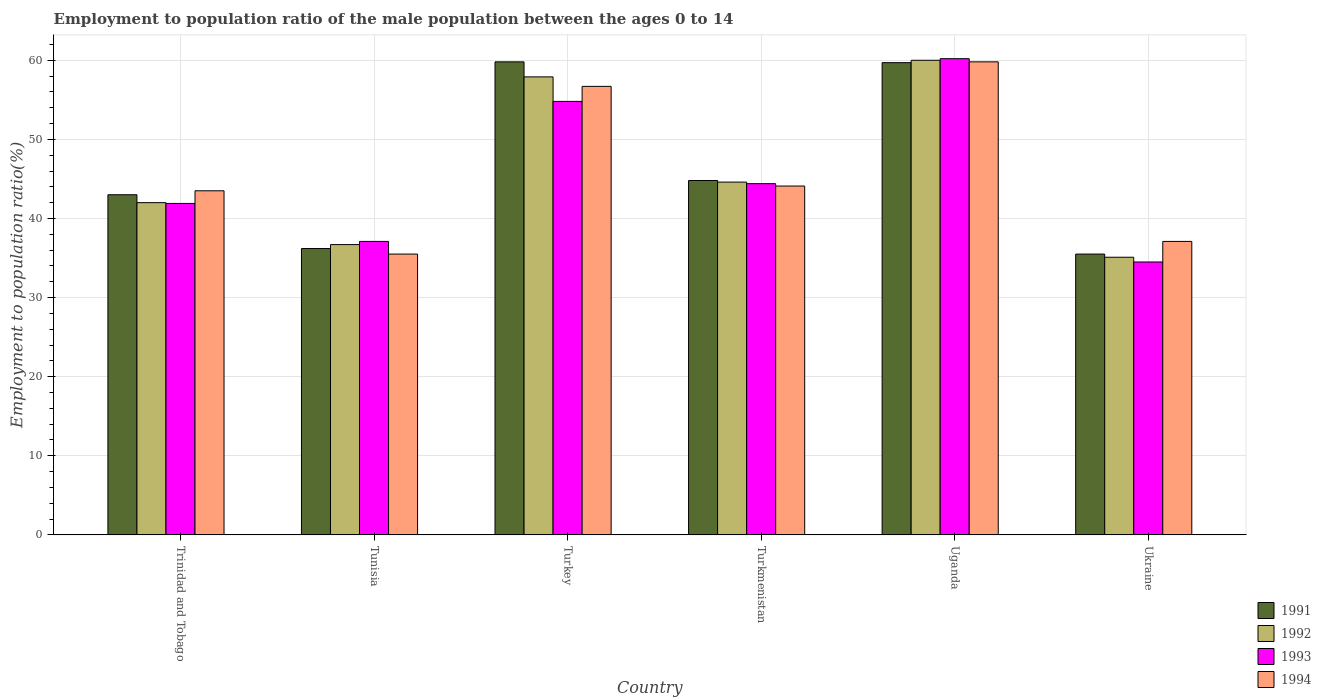How many groups of bars are there?
Give a very brief answer. 6. Are the number of bars per tick equal to the number of legend labels?
Keep it short and to the point. Yes. Are the number of bars on each tick of the X-axis equal?
Ensure brevity in your answer.  Yes. What is the label of the 4th group of bars from the left?
Give a very brief answer. Turkmenistan. What is the employment to population ratio in 1991 in Uganda?
Your response must be concise. 59.7. Across all countries, what is the maximum employment to population ratio in 1993?
Offer a terse response. 60.2. Across all countries, what is the minimum employment to population ratio in 1994?
Provide a short and direct response. 35.5. In which country was the employment to population ratio in 1991 minimum?
Your answer should be very brief. Ukraine. What is the total employment to population ratio in 1992 in the graph?
Provide a short and direct response. 276.3. What is the difference between the employment to population ratio in 1991 in Tunisia and the employment to population ratio in 1993 in Turkmenistan?
Provide a short and direct response. -8.2. What is the average employment to population ratio in 1992 per country?
Offer a very short reply. 46.05. What is the difference between the employment to population ratio of/in 1994 and employment to population ratio of/in 1993 in Trinidad and Tobago?
Provide a succinct answer. 1.6. What is the ratio of the employment to population ratio in 1993 in Turkey to that in Uganda?
Provide a succinct answer. 0.91. Is the difference between the employment to population ratio in 1994 in Turkey and Ukraine greater than the difference between the employment to population ratio in 1993 in Turkey and Ukraine?
Your answer should be very brief. No. What is the difference between the highest and the second highest employment to population ratio in 1991?
Keep it short and to the point. -0.1. What is the difference between the highest and the lowest employment to population ratio in 1992?
Your response must be concise. 24.9. In how many countries, is the employment to population ratio in 1991 greater than the average employment to population ratio in 1991 taken over all countries?
Keep it short and to the point. 2. Is it the case that in every country, the sum of the employment to population ratio in 1993 and employment to population ratio in 1992 is greater than the sum of employment to population ratio in 1991 and employment to population ratio in 1994?
Offer a very short reply. No. Is it the case that in every country, the sum of the employment to population ratio in 1994 and employment to population ratio in 1991 is greater than the employment to population ratio in 1992?
Provide a succinct answer. Yes. How many bars are there?
Ensure brevity in your answer.  24. Are all the bars in the graph horizontal?
Your response must be concise. No. How many countries are there in the graph?
Offer a very short reply. 6. What is the difference between two consecutive major ticks on the Y-axis?
Offer a very short reply. 10. Where does the legend appear in the graph?
Give a very brief answer. Bottom right. How many legend labels are there?
Provide a succinct answer. 4. How are the legend labels stacked?
Your answer should be compact. Vertical. What is the title of the graph?
Offer a terse response. Employment to population ratio of the male population between the ages 0 to 14. Does "2002" appear as one of the legend labels in the graph?
Provide a short and direct response. No. What is the label or title of the Y-axis?
Make the answer very short. Employment to population ratio(%). What is the Employment to population ratio(%) in 1991 in Trinidad and Tobago?
Your answer should be compact. 43. What is the Employment to population ratio(%) of 1992 in Trinidad and Tobago?
Provide a succinct answer. 42. What is the Employment to population ratio(%) in 1993 in Trinidad and Tobago?
Your answer should be compact. 41.9. What is the Employment to population ratio(%) of 1994 in Trinidad and Tobago?
Provide a succinct answer. 43.5. What is the Employment to population ratio(%) in 1991 in Tunisia?
Keep it short and to the point. 36.2. What is the Employment to population ratio(%) of 1992 in Tunisia?
Offer a very short reply. 36.7. What is the Employment to population ratio(%) of 1993 in Tunisia?
Your answer should be very brief. 37.1. What is the Employment to population ratio(%) in 1994 in Tunisia?
Make the answer very short. 35.5. What is the Employment to population ratio(%) of 1991 in Turkey?
Offer a terse response. 59.8. What is the Employment to population ratio(%) of 1992 in Turkey?
Offer a terse response. 57.9. What is the Employment to population ratio(%) in 1993 in Turkey?
Provide a succinct answer. 54.8. What is the Employment to population ratio(%) in 1994 in Turkey?
Provide a succinct answer. 56.7. What is the Employment to population ratio(%) of 1991 in Turkmenistan?
Keep it short and to the point. 44.8. What is the Employment to population ratio(%) in 1992 in Turkmenistan?
Offer a very short reply. 44.6. What is the Employment to population ratio(%) of 1993 in Turkmenistan?
Keep it short and to the point. 44.4. What is the Employment to population ratio(%) of 1994 in Turkmenistan?
Your response must be concise. 44.1. What is the Employment to population ratio(%) in 1991 in Uganda?
Ensure brevity in your answer.  59.7. What is the Employment to population ratio(%) in 1992 in Uganda?
Make the answer very short. 60. What is the Employment to population ratio(%) of 1993 in Uganda?
Offer a terse response. 60.2. What is the Employment to population ratio(%) of 1994 in Uganda?
Offer a terse response. 59.8. What is the Employment to population ratio(%) in 1991 in Ukraine?
Offer a terse response. 35.5. What is the Employment to population ratio(%) in 1992 in Ukraine?
Offer a terse response. 35.1. What is the Employment to population ratio(%) in 1993 in Ukraine?
Ensure brevity in your answer.  34.5. What is the Employment to population ratio(%) in 1994 in Ukraine?
Keep it short and to the point. 37.1. Across all countries, what is the maximum Employment to population ratio(%) in 1991?
Keep it short and to the point. 59.8. Across all countries, what is the maximum Employment to population ratio(%) in 1992?
Provide a short and direct response. 60. Across all countries, what is the maximum Employment to population ratio(%) of 1993?
Give a very brief answer. 60.2. Across all countries, what is the maximum Employment to population ratio(%) in 1994?
Offer a terse response. 59.8. Across all countries, what is the minimum Employment to population ratio(%) in 1991?
Ensure brevity in your answer.  35.5. Across all countries, what is the minimum Employment to population ratio(%) of 1992?
Offer a terse response. 35.1. Across all countries, what is the minimum Employment to population ratio(%) of 1993?
Give a very brief answer. 34.5. Across all countries, what is the minimum Employment to population ratio(%) in 1994?
Your response must be concise. 35.5. What is the total Employment to population ratio(%) of 1991 in the graph?
Offer a very short reply. 279. What is the total Employment to population ratio(%) of 1992 in the graph?
Give a very brief answer. 276.3. What is the total Employment to population ratio(%) in 1993 in the graph?
Your answer should be very brief. 272.9. What is the total Employment to population ratio(%) in 1994 in the graph?
Your response must be concise. 276.7. What is the difference between the Employment to population ratio(%) of 1991 in Trinidad and Tobago and that in Tunisia?
Provide a short and direct response. 6.8. What is the difference between the Employment to population ratio(%) in 1992 in Trinidad and Tobago and that in Tunisia?
Keep it short and to the point. 5.3. What is the difference between the Employment to population ratio(%) in 1991 in Trinidad and Tobago and that in Turkey?
Your response must be concise. -16.8. What is the difference between the Employment to population ratio(%) in 1992 in Trinidad and Tobago and that in Turkey?
Offer a very short reply. -15.9. What is the difference between the Employment to population ratio(%) of 1991 in Trinidad and Tobago and that in Turkmenistan?
Your answer should be compact. -1.8. What is the difference between the Employment to population ratio(%) of 1992 in Trinidad and Tobago and that in Turkmenistan?
Your response must be concise. -2.6. What is the difference between the Employment to population ratio(%) of 1993 in Trinidad and Tobago and that in Turkmenistan?
Your answer should be compact. -2.5. What is the difference between the Employment to population ratio(%) of 1994 in Trinidad and Tobago and that in Turkmenistan?
Your response must be concise. -0.6. What is the difference between the Employment to population ratio(%) of 1991 in Trinidad and Tobago and that in Uganda?
Provide a short and direct response. -16.7. What is the difference between the Employment to population ratio(%) of 1992 in Trinidad and Tobago and that in Uganda?
Your answer should be very brief. -18. What is the difference between the Employment to population ratio(%) of 1993 in Trinidad and Tobago and that in Uganda?
Offer a terse response. -18.3. What is the difference between the Employment to population ratio(%) of 1994 in Trinidad and Tobago and that in Uganda?
Your answer should be very brief. -16.3. What is the difference between the Employment to population ratio(%) of 1991 in Trinidad and Tobago and that in Ukraine?
Your answer should be very brief. 7.5. What is the difference between the Employment to population ratio(%) in 1994 in Trinidad and Tobago and that in Ukraine?
Your answer should be very brief. 6.4. What is the difference between the Employment to population ratio(%) of 1991 in Tunisia and that in Turkey?
Your answer should be very brief. -23.6. What is the difference between the Employment to population ratio(%) of 1992 in Tunisia and that in Turkey?
Ensure brevity in your answer.  -21.2. What is the difference between the Employment to population ratio(%) of 1993 in Tunisia and that in Turkey?
Offer a terse response. -17.7. What is the difference between the Employment to population ratio(%) of 1994 in Tunisia and that in Turkey?
Provide a short and direct response. -21.2. What is the difference between the Employment to population ratio(%) in 1991 in Tunisia and that in Turkmenistan?
Your answer should be very brief. -8.6. What is the difference between the Employment to population ratio(%) of 1991 in Tunisia and that in Uganda?
Give a very brief answer. -23.5. What is the difference between the Employment to population ratio(%) of 1992 in Tunisia and that in Uganda?
Your answer should be compact. -23.3. What is the difference between the Employment to population ratio(%) of 1993 in Tunisia and that in Uganda?
Ensure brevity in your answer.  -23.1. What is the difference between the Employment to population ratio(%) in 1994 in Tunisia and that in Uganda?
Provide a succinct answer. -24.3. What is the difference between the Employment to population ratio(%) in 1991 in Tunisia and that in Ukraine?
Give a very brief answer. 0.7. What is the difference between the Employment to population ratio(%) in 1992 in Tunisia and that in Ukraine?
Make the answer very short. 1.6. What is the difference between the Employment to population ratio(%) of 1993 in Tunisia and that in Ukraine?
Offer a very short reply. 2.6. What is the difference between the Employment to population ratio(%) of 1993 in Turkey and that in Uganda?
Your answer should be compact. -5.4. What is the difference between the Employment to population ratio(%) of 1994 in Turkey and that in Uganda?
Your answer should be very brief. -3.1. What is the difference between the Employment to population ratio(%) in 1991 in Turkey and that in Ukraine?
Keep it short and to the point. 24.3. What is the difference between the Employment to population ratio(%) in 1992 in Turkey and that in Ukraine?
Keep it short and to the point. 22.8. What is the difference between the Employment to population ratio(%) in 1993 in Turkey and that in Ukraine?
Give a very brief answer. 20.3. What is the difference between the Employment to population ratio(%) in 1994 in Turkey and that in Ukraine?
Ensure brevity in your answer.  19.6. What is the difference between the Employment to population ratio(%) in 1991 in Turkmenistan and that in Uganda?
Ensure brevity in your answer.  -14.9. What is the difference between the Employment to population ratio(%) of 1992 in Turkmenistan and that in Uganda?
Provide a succinct answer. -15.4. What is the difference between the Employment to population ratio(%) in 1993 in Turkmenistan and that in Uganda?
Offer a very short reply. -15.8. What is the difference between the Employment to population ratio(%) of 1994 in Turkmenistan and that in Uganda?
Make the answer very short. -15.7. What is the difference between the Employment to population ratio(%) of 1991 in Turkmenistan and that in Ukraine?
Your answer should be very brief. 9.3. What is the difference between the Employment to population ratio(%) of 1994 in Turkmenistan and that in Ukraine?
Your response must be concise. 7. What is the difference between the Employment to population ratio(%) in 1991 in Uganda and that in Ukraine?
Offer a very short reply. 24.2. What is the difference between the Employment to population ratio(%) in 1992 in Uganda and that in Ukraine?
Provide a short and direct response. 24.9. What is the difference between the Employment to population ratio(%) in 1993 in Uganda and that in Ukraine?
Offer a very short reply. 25.7. What is the difference between the Employment to population ratio(%) of 1994 in Uganda and that in Ukraine?
Your answer should be compact. 22.7. What is the difference between the Employment to population ratio(%) in 1991 in Trinidad and Tobago and the Employment to population ratio(%) in 1992 in Tunisia?
Your response must be concise. 6.3. What is the difference between the Employment to population ratio(%) in 1991 in Trinidad and Tobago and the Employment to population ratio(%) in 1994 in Tunisia?
Offer a terse response. 7.5. What is the difference between the Employment to population ratio(%) of 1992 in Trinidad and Tobago and the Employment to population ratio(%) of 1994 in Tunisia?
Offer a very short reply. 6.5. What is the difference between the Employment to population ratio(%) in 1991 in Trinidad and Tobago and the Employment to population ratio(%) in 1992 in Turkey?
Offer a very short reply. -14.9. What is the difference between the Employment to population ratio(%) in 1991 in Trinidad and Tobago and the Employment to population ratio(%) in 1994 in Turkey?
Provide a succinct answer. -13.7. What is the difference between the Employment to population ratio(%) of 1992 in Trinidad and Tobago and the Employment to population ratio(%) of 1994 in Turkey?
Your answer should be compact. -14.7. What is the difference between the Employment to population ratio(%) of 1993 in Trinidad and Tobago and the Employment to population ratio(%) of 1994 in Turkey?
Your answer should be very brief. -14.8. What is the difference between the Employment to population ratio(%) of 1991 in Trinidad and Tobago and the Employment to population ratio(%) of 1992 in Turkmenistan?
Your answer should be very brief. -1.6. What is the difference between the Employment to population ratio(%) of 1991 in Trinidad and Tobago and the Employment to population ratio(%) of 1994 in Turkmenistan?
Provide a short and direct response. -1.1. What is the difference between the Employment to population ratio(%) in 1992 in Trinidad and Tobago and the Employment to population ratio(%) in 1993 in Turkmenistan?
Your answer should be compact. -2.4. What is the difference between the Employment to population ratio(%) in 1991 in Trinidad and Tobago and the Employment to population ratio(%) in 1993 in Uganda?
Provide a succinct answer. -17.2. What is the difference between the Employment to population ratio(%) of 1991 in Trinidad and Tobago and the Employment to population ratio(%) of 1994 in Uganda?
Make the answer very short. -16.8. What is the difference between the Employment to population ratio(%) in 1992 in Trinidad and Tobago and the Employment to population ratio(%) in 1993 in Uganda?
Offer a very short reply. -18.2. What is the difference between the Employment to population ratio(%) of 1992 in Trinidad and Tobago and the Employment to population ratio(%) of 1994 in Uganda?
Your answer should be compact. -17.8. What is the difference between the Employment to population ratio(%) of 1993 in Trinidad and Tobago and the Employment to population ratio(%) of 1994 in Uganda?
Your response must be concise. -17.9. What is the difference between the Employment to population ratio(%) of 1991 in Trinidad and Tobago and the Employment to population ratio(%) of 1992 in Ukraine?
Keep it short and to the point. 7.9. What is the difference between the Employment to population ratio(%) in 1991 in Tunisia and the Employment to population ratio(%) in 1992 in Turkey?
Give a very brief answer. -21.7. What is the difference between the Employment to population ratio(%) of 1991 in Tunisia and the Employment to population ratio(%) of 1993 in Turkey?
Provide a succinct answer. -18.6. What is the difference between the Employment to population ratio(%) of 1991 in Tunisia and the Employment to population ratio(%) of 1994 in Turkey?
Ensure brevity in your answer.  -20.5. What is the difference between the Employment to population ratio(%) in 1992 in Tunisia and the Employment to population ratio(%) in 1993 in Turkey?
Your answer should be very brief. -18.1. What is the difference between the Employment to population ratio(%) in 1992 in Tunisia and the Employment to population ratio(%) in 1994 in Turkey?
Your answer should be compact. -20. What is the difference between the Employment to population ratio(%) in 1993 in Tunisia and the Employment to population ratio(%) in 1994 in Turkey?
Provide a succinct answer. -19.6. What is the difference between the Employment to population ratio(%) of 1992 in Tunisia and the Employment to population ratio(%) of 1994 in Turkmenistan?
Your answer should be compact. -7.4. What is the difference between the Employment to population ratio(%) in 1993 in Tunisia and the Employment to population ratio(%) in 1994 in Turkmenistan?
Provide a short and direct response. -7. What is the difference between the Employment to population ratio(%) of 1991 in Tunisia and the Employment to population ratio(%) of 1992 in Uganda?
Offer a terse response. -23.8. What is the difference between the Employment to population ratio(%) in 1991 in Tunisia and the Employment to population ratio(%) in 1994 in Uganda?
Offer a very short reply. -23.6. What is the difference between the Employment to population ratio(%) in 1992 in Tunisia and the Employment to population ratio(%) in 1993 in Uganda?
Offer a very short reply. -23.5. What is the difference between the Employment to population ratio(%) of 1992 in Tunisia and the Employment to population ratio(%) of 1994 in Uganda?
Give a very brief answer. -23.1. What is the difference between the Employment to population ratio(%) in 1993 in Tunisia and the Employment to population ratio(%) in 1994 in Uganda?
Make the answer very short. -22.7. What is the difference between the Employment to population ratio(%) in 1991 in Tunisia and the Employment to population ratio(%) in 1992 in Ukraine?
Your answer should be very brief. 1.1. What is the difference between the Employment to population ratio(%) in 1991 in Tunisia and the Employment to population ratio(%) in 1994 in Ukraine?
Keep it short and to the point. -0.9. What is the difference between the Employment to population ratio(%) in 1993 in Tunisia and the Employment to population ratio(%) in 1994 in Ukraine?
Provide a short and direct response. 0. What is the difference between the Employment to population ratio(%) in 1991 in Turkey and the Employment to population ratio(%) in 1992 in Turkmenistan?
Offer a terse response. 15.2. What is the difference between the Employment to population ratio(%) in 1992 in Turkey and the Employment to population ratio(%) in 1993 in Turkmenistan?
Offer a terse response. 13.5. What is the difference between the Employment to population ratio(%) of 1993 in Turkey and the Employment to population ratio(%) of 1994 in Turkmenistan?
Offer a very short reply. 10.7. What is the difference between the Employment to population ratio(%) in 1991 in Turkey and the Employment to population ratio(%) in 1993 in Uganda?
Your answer should be compact. -0.4. What is the difference between the Employment to population ratio(%) in 1991 in Turkey and the Employment to population ratio(%) in 1994 in Uganda?
Make the answer very short. 0. What is the difference between the Employment to population ratio(%) in 1992 in Turkey and the Employment to population ratio(%) in 1993 in Uganda?
Give a very brief answer. -2.3. What is the difference between the Employment to population ratio(%) in 1992 in Turkey and the Employment to population ratio(%) in 1994 in Uganda?
Offer a terse response. -1.9. What is the difference between the Employment to population ratio(%) of 1993 in Turkey and the Employment to population ratio(%) of 1994 in Uganda?
Offer a terse response. -5. What is the difference between the Employment to population ratio(%) of 1991 in Turkey and the Employment to population ratio(%) of 1992 in Ukraine?
Make the answer very short. 24.7. What is the difference between the Employment to population ratio(%) of 1991 in Turkey and the Employment to population ratio(%) of 1993 in Ukraine?
Your answer should be very brief. 25.3. What is the difference between the Employment to population ratio(%) in 1991 in Turkey and the Employment to population ratio(%) in 1994 in Ukraine?
Your answer should be very brief. 22.7. What is the difference between the Employment to population ratio(%) in 1992 in Turkey and the Employment to population ratio(%) in 1993 in Ukraine?
Offer a very short reply. 23.4. What is the difference between the Employment to population ratio(%) in 1992 in Turkey and the Employment to population ratio(%) in 1994 in Ukraine?
Provide a succinct answer. 20.8. What is the difference between the Employment to population ratio(%) in 1991 in Turkmenistan and the Employment to population ratio(%) in 1992 in Uganda?
Provide a succinct answer. -15.2. What is the difference between the Employment to population ratio(%) of 1991 in Turkmenistan and the Employment to population ratio(%) of 1993 in Uganda?
Your answer should be very brief. -15.4. What is the difference between the Employment to population ratio(%) in 1991 in Turkmenistan and the Employment to population ratio(%) in 1994 in Uganda?
Provide a succinct answer. -15. What is the difference between the Employment to population ratio(%) of 1992 in Turkmenistan and the Employment to population ratio(%) of 1993 in Uganda?
Your response must be concise. -15.6. What is the difference between the Employment to population ratio(%) in 1992 in Turkmenistan and the Employment to population ratio(%) in 1994 in Uganda?
Your response must be concise. -15.2. What is the difference between the Employment to population ratio(%) in 1993 in Turkmenistan and the Employment to population ratio(%) in 1994 in Uganda?
Provide a short and direct response. -15.4. What is the difference between the Employment to population ratio(%) in 1991 in Turkmenistan and the Employment to population ratio(%) in 1994 in Ukraine?
Your response must be concise. 7.7. What is the difference between the Employment to population ratio(%) in 1993 in Turkmenistan and the Employment to population ratio(%) in 1994 in Ukraine?
Give a very brief answer. 7.3. What is the difference between the Employment to population ratio(%) in 1991 in Uganda and the Employment to population ratio(%) in 1992 in Ukraine?
Provide a short and direct response. 24.6. What is the difference between the Employment to population ratio(%) in 1991 in Uganda and the Employment to population ratio(%) in 1993 in Ukraine?
Provide a succinct answer. 25.2. What is the difference between the Employment to population ratio(%) in 1991 in Uganda and the Employment to population ratio(%) in 1994 in Ukraine?
Offer a terse response. 22.6. What is the difference between the Employment to population ratio(%) in 1992 in Uganda and the Employment to population ratio(%) in 1994 in Ukraine?
Provide a succinct answer. 22.9. What is the difference between the Employment to population ratio(%) of 1993 in Uganda and the Employment to population ratio(%) of 1994 in Ukraine?
Offer a very short reply. 23.1. What is the average Employment to population ratio(%) in 1991 per country?
Provide a succinct answer. 46.5. What is the average Employment to population ratio(%) of 1992 per country?
Keep it short and to the point. 46.05. What is the average Employment to population ratio(%) in 1993 per country?
Provide a succinct answer. 45.48. What is the average Employment to population ratio(%) of 1994 per country?
Ensure brevity in your answer.  46.12. What is the difference between the Employment to population ratio(%) in 1991 and Employment to population ratio(%) in 1992 in Trinidad and Tobago?
Your answer should be very brief. 1. What is the difference between the Employment to population ratio(%) of 1991 and Employment to population ratio(%) of 1993 in Trinidad and Tobago?
Keep it short and to the point. 1.1. What is the difference between the Employment to population ratio(%) of 1991 and Employment to population ratio(%) of 1994 in Trinidad and Tobago?
Provide a short and direct response. -0.5. What is the difference between the Employment to population ratio(%) in 1992 and Employment to population ratio(%) in 1993 in Trinidad and Tobago?
Ensure brevity in your answer.  0.1. What is the difference between the Employment to population ratio(%) in 1993 and Employment to population ratio(%) in 1994 in Trinidad and Tobago?
Your answer should be compact. -1.6. What is the difference between the Employment to population ratio(%) of 1991 and Employment to population ratio(%) of 1992 in Tunisia?
Give a very brief answer. -0.5. What is the difference between the Employment to population ratio(%) of 1991 and Employment to population ratio(%) of 1993 in Tunisia?
Your answer should be very brief. -0.9. What is the difference between the Employment to population ratio(%) in 1991 and Employment to population ratio(%) in 1994 in Tunisia?
Offer a terse response. 0.7. What is the difference between the Employment to population ratio(%) in 1992 and Employment to population ratio(%) in 1993 in Tunisia?
Your answer should be very brief. -0.4. What is the difference between the Employment to population ratio(%) of 1992 and Employment to population ratio(%) of 1994 in Tunisia?
Keep it short and to the point. 1.2. What is the difference between the Employment to population ratio(%) of 1993 and Employment to population ratio(%) of 1994 in Tunisia?
Your answer should be very brief. 1.6. What is the difference between the Employment to population ratio(%) of 1992 and Employment to population ratio(%) of 1993 in Turkey?
Keep it short and to the point. 3.1. What is the difference between the Employment to population ratio(%) of 1992 and Employment to population ratio(%) of 1994 in Turkey?
Offer a very short reply. 1.2. What is the difference between the Employment to population ratio(%) of 1993 and Employment to population ratio(%) of 1994 in Turkey?
Keep it short and to the point. -1.9. What is the difference between the Employment to population ratio(%) in 1991 and Employment to population ratio(%) in 1992 in Turkmenistan?
Offer a terse response. 0.2. What is the difference between the Employment to population ratio(%) of 1992 and Employment to population ratio(%) of 1993 in Turkmenistan?
Offer a terse response. 0.2. What is the difference between the Employment to population ratio(%) in 1993 and Employment to population ratio(%) in 1994 in Turkmenistan?
Ensure brevity in your answer.  0.3. What is the difference between the Employment to population ratio(%) of 1991 and Employment to population ratio(%) of 1992 in Uganda?
Give a very brief answer. -0.3. What is the difference between the Employment to population ratio(%) of 1991 and Employment to population ratio(%) of 1993 in Ukraine?
Keep it short and to the point. 1. What is the difference between the Employment to population ratio(%) in 1992 and Employment to population ratio(%) in 1993 in Ukraine?
Your answer should be very brief. 0.6. What is the ratio of the Employment to population ratio(%) in 1991 in Trinidad and Tobago to that in Tunisia?
Make the answer very short. 1.19. What is the ratio of the Employment to population ratio(%) of 1992 in Trinidad and Tobago to that in Tunisia?
Your answer should be very brief. 1.14. What is the ratio of the Employment to population ratio(%) in 1993 in Trinidad and Tobago to that in Tunisia?
Provide a short and direct response. 1.13. What is the ratio of the Employment to population ratio(%) of 1994 in Trinidad and Tobago to that in Tunisia?
Provide a succinct answer. 1.23. What is the ratio of the Employment to population ratio(%) of 1991 in Trinidad and Tobago to that in Turkey?
Your response must be concise. 0.72. What is the ratio of the Employment to population ratio(%) of 1992 in Trinidad and Tobago to that in Turkey?
Keep it short and to the point. 0.73. What is the ratio of the Employment to population ratio(%) of 1993 in Trinidad and Tobago to that in Turkey?
Make the answer very short. 0.76. What is the ratio of the Employment to population ratio(%) in 1994 in Trinidad and Tobago to that in Turkey?
Provide a short and direct response. 0.77. What is the ratio of the Employment to population ratio(%) of 1991 in Trinidad and Tobago to that in Turkmenistan?
Offer a terse response. 0.96. What is the ratio of the Employment to population ratio(%) in 1992 in Trinidad and Tobago to that in Turkmenistan?
Give a very brief answer. 0.94. What is the ratio of the Employment to population ratio(%) of 1993 in Trinidad and Tobago to that in Turkmenistan?
Your answer should be compact. 0.94. What is the ratio of the Employment to population ratio(%) of 1994 in Trinidad and Tobago to that in Turkmenistan?
Provide a succinct answer. 0.99. What is the ratio of the Employment to population ratio(%) of 1991 in Trinidad and Tobago to that in Uganda?
Your response must be concise. 0.72. What is the ratio of the Employment to population ratio(%) of 1992 in Trinidad and Tobago to that in Uganda?
Your response must be concise. 0.7. What is the ratio of the Employment to population ratio(%) of 1993 in Trinidad and Tobago to that in Uganda?
Keep it short and to the point. 0.7. What is the ratio of the Employment to population ratio(%) of 1994 in Trinidad and Tobago to that in Uganda?
Ensure brevity in your answer.  0.73. What is the ratio of the Employment to population ratio(%) in 1991 in Trinidad and Tobago to that in Ukraine?
Your answer should be compact. 1.21. What is the ratio of the Employment to population ratio(%) in 1992 in Trinidad and Tobago to that in Ukraine?
Offer a terse response. 1.2. What is the ratio of the Employment to population ratio(%) of 1993 in Trinidad and Tobago to that in Ukraine?
Make the answer very short. 1.21. What is the ratio of the Employment to population ratio(%) in 1994 in Trinidad and Tobago to that in Ukraine?
Your response must be concise. 1.17. What is the ratio of the Employment to population ratio(%) of 1991 in Tunisia to that in Turkey?
Provide a succinct answer. 0.61. What is the ratio of the Employment to population ratio(%) in 1992 in Tunisia to that in Turkey?
Ensure brevity in your answer.  0.63. What is the ratio of the Employment to population ratio(%) in 1993 in Tunisia to that in Turkey?
Offer a terse response. 0.68. What is the ratio of the Employment to population ratio(%) of 1994 in Tunisia to that in Turkey?
Provide a short and direct response. 0.63. What is the ratio of the Employment to population ratio(%) in 1991 in Tunisia to that in Turkmenistan?
Your answer should be compact. 0.81. What is the ratio of the Employment to population ratio(%) in 1992 in Tunisia to that in Turkmenistan?
Offer a very short reply. 0.82. What is the ratio of the Employment to population ratio(%) in 1993 in Tunisia to that in Turkmenistan?
Your answer should be compact. 0.84. What is the ratio of the Employment to population ratio(%) of 1994 in Tunisia to that in Turkmenistan?
Make the answer very short. 0.81. What is the ratio of the Employment to population ratio(%) of 1991 in Tunisia to that in Uganda?
Your response must be concise. 0.61. What is the ratio of the Employment to population ratio(%) in 1992 in Tunisia to that in Uganda?
Offer a terse response. 0.61. What is the ratio of the Employment to population ratio(%) of 1993 in Tunisia to that in Uganda?
Keep it short and to the point. 0.62. What is the ratio of the Employment to population ratio(%) in 1994 in Tunisia to that in Uganda?
Provide a short and direct response. 0.59. What is the ratio of the Employment to population ratio(%) in 1991 in Tunisia to that in Ukraine?
Offer a very short reply. 1.02. What is the ratio of the Employment to population ratio(%) of 1992 in Tunisia to that in Ukraine?
Provide a succinct answer. 1.05. What is the ratio of the Employment to population ratio(%) in 1993 in Tunisia to that in Ukraine?
Make the answer very short. 1.08. What is the ratio of the Employment to population ratio(%) of 1994 in Tunisia to that in Ukraine?
Offer a very short reply. 0.96. What is the ratio of the Employment to population ratio(%) of 1991 in Turkey to that in Turkmenistan?
Keep it short and to the point. 1.33. What is the ratio of the Employment to population ratio(%) in 1992 in Turkey to that in Turkmenistan?
Give a very brief answer. 1.3. What is the ratio of the Employment to population ratio(%) in 1993 in Turkey to that in Turkmenistan?
Your answer should be very brief. 1.23. What is the ratio of the Employment to population ratio(%) in 1994 in Turkey to that in Turkmenistan?
Give a very brief answer. 1.29. What is the ratio of the Employment to population ratio(%) of 1993 in Turkey to that in Uganda?
Your response must be concise. 0.91. What is the ratio of the Employment to population ratio(%) of 1994 in Turkey to that in Uganda?
Provide a succinct answer. 0.95. What is the ratio of the Employment to population ratio(%) in 1991 in Turkey to that in Ukraine?
Your answer should be compact. 1.68. What is the ratio of the Employment to population ratio(%) of 1992 in Turkey to that in Ukraine?
Offer a very short reply. 1.65. What is the ratio of the Employment to population ratio(%) in 1993 in Turkey to that in Ukraine?
Offer a terse response. 1.59. What is the ratio of the Employment to population ratio(%) of 1994 in Turkey to that in Ukraine?
Ensure brevity in your answer.  1.53. What is the ratio of the Employment to population ratio(%) of 1991 in Turkmenistan to that in Uganda?
Your answer should be very brief. 0.75. What is the ratio of the Employment to population ratio(%) of 1992 in Turkmenistan to that in Uganda?
Your answer should be very brief. 0.74. What is the ratio of the Employment to population ratio(%) in 1993 in Turkmenistan to that in Uganda?
Keep it short and to the point. 0.74. What is the ratio of the Employment to population ratio(%) of 1994 in Turkmenistan to that in Uganda?
Your response must be concise. 0.74. What is the ratio of the Employment to population ratio(%) in 1991 in Turkmenistan to that in Ukraine?
Your response must be concise. 1.26. What is the ratio of the Employment to population ratio(%) in 1992 in Turkmenistan to that in Ukraine?
Your answer should be compact. 1.27. What is the ratio of the Employment to population ratio(%) in 1993 in Turkmenistan to that in Ukraine?
Provide a succinct answer. 1.29. What is the ratio of the Employment to population ratio(%) in 1994 in Turkmenistan to that in Ukraine?
Make the answer very short. 1.19. What is the ratio of the Employment to population ratio(%) of 1991 in Uganda to that in Ukraine?
Your response must be concise. 1.68. What is the ratio of the Employment to population ratio(%) in 1992 in Uganda to that in Ukraine?
Your response must be concise. 1.71. What is the ratio of the Employment to population ratio(%) in 1993 in Uganda to that in Ukraine?
Your response must be concise. 1.74. What is the ratio of the Employment to population ratio(%) of 1994 in Uganda to that in Ukraine?
Keep it short and to the point. 1.61. What is the difference between the highest and the second highest Employment to population ratio(%) of 1992?
Your response must be concise. 2.1. What is the difference between the highest and the second highest Employment to population ratio(%) of 1993?
Offer a terse response. 5.4. What is the difference between the highest and the lowest Employment to population ratio(%) of 1991?
Your response must be concise. 24.3. What is the difference between the highest and the lowest Employment to population ratio(%) in 1992?
Give a very brief answer. 24.9. What is the difference between the highest and the lowest Employment to population ratio(%) in 1993?
Keep it short and to the point. 25.7. What is the difference between the highest and the lowest Employment to population ratio(%) of 1994?
Make the answer very short. 24.3. 